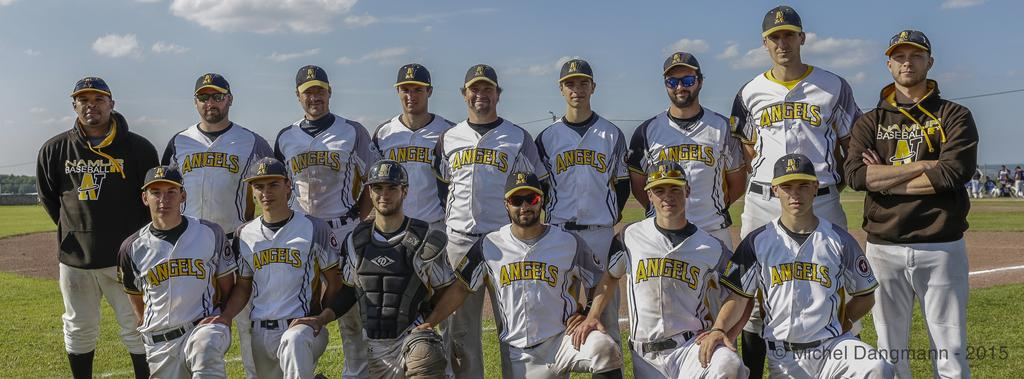<image>
Relay a brief, clear account of the picture shown. a team for the Angels baseball league stand together for a portrait 